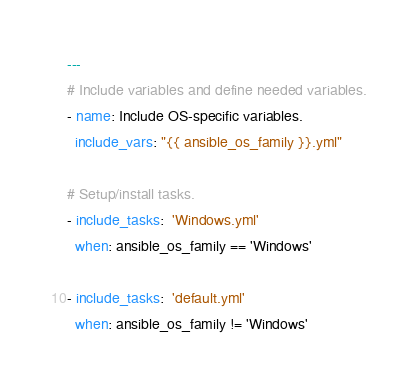<code> <loc_0><loc_0><loc_500><loc_500><_YAML_>---
# Include variables and define needed variables.
- name: Include OS-specific variables.
  include_vars: "{{ ansible_os_family }}.yml"

# Setup/install tasks.
- include_tasks:  'Windows.yml'
  when: ansible_os_family == 'Windows'

- include_tasks:  'default.yml'
  when: ansible_os_family != 'Windows'


</code> 